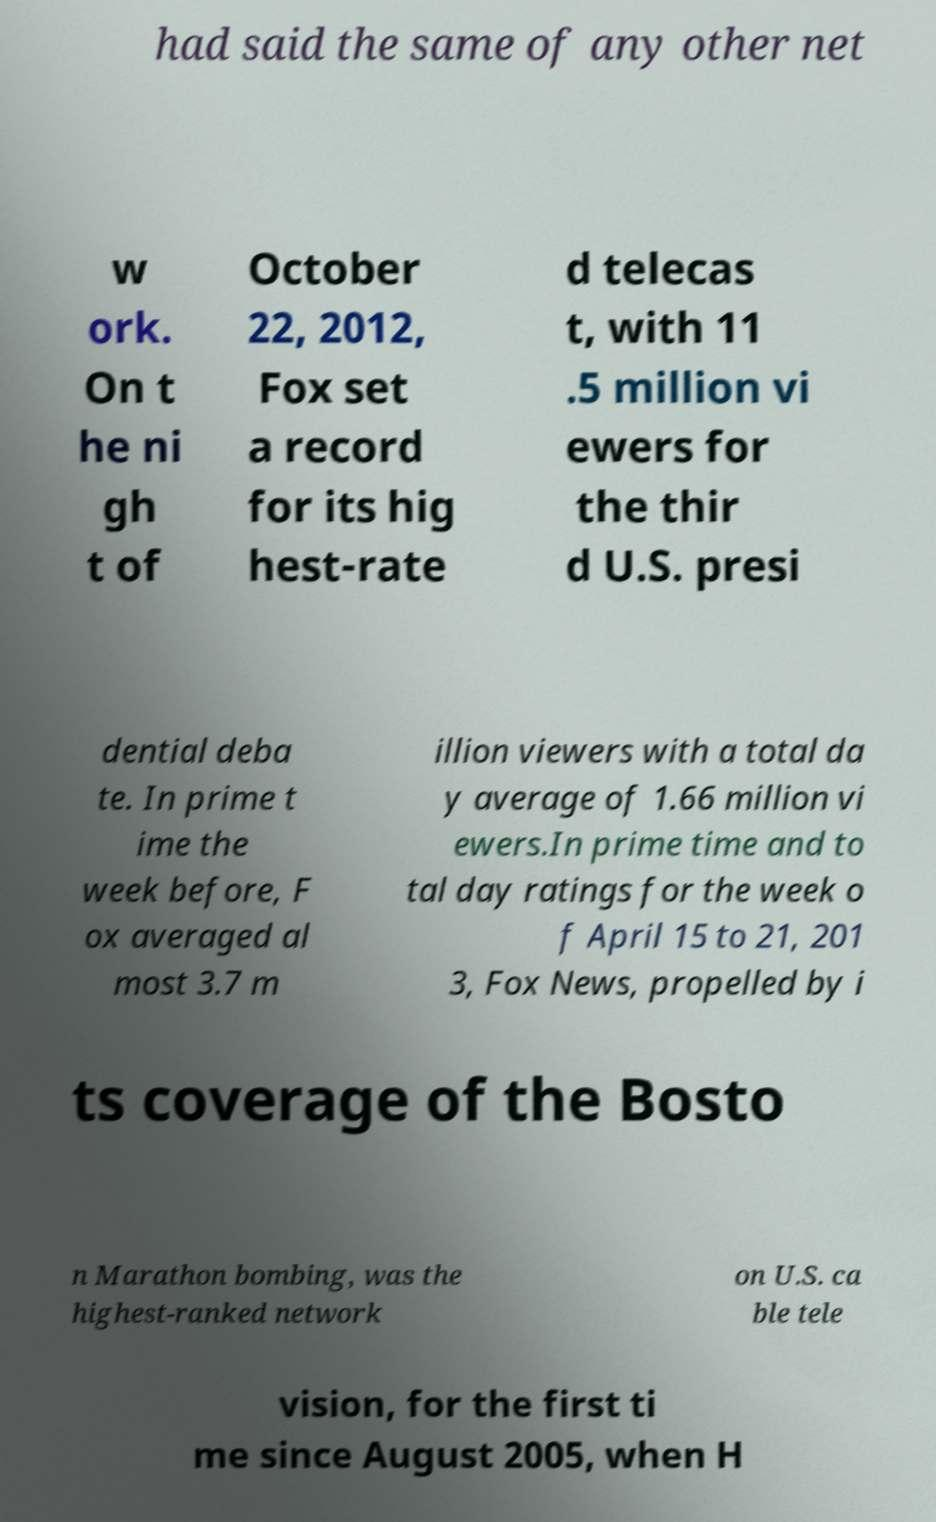There's text embedded in this image that I need extracted. Can you transcribe it verbatim? had said the same of any other net w ork. On t he ni gh t of October 22, 2012, Fox set a record for its hig hest-rate d telecas t, with 11 .5 million vi ewers for the thir d U.S. presi dential deba te. In prime t ime the week before, F ox averaged al most 3.7 m illion viewers with a total da y average of 1.66 million vi ewers.In prime time and to tal day ratings for the week o f April 15 to 21, 201 3, Fox News, propelled by i ts coverage of the Bosto n Marathon bombing, was the highest-ranked network on U.S. ca ble tele vision, for the first ti me since August 2005, when H 